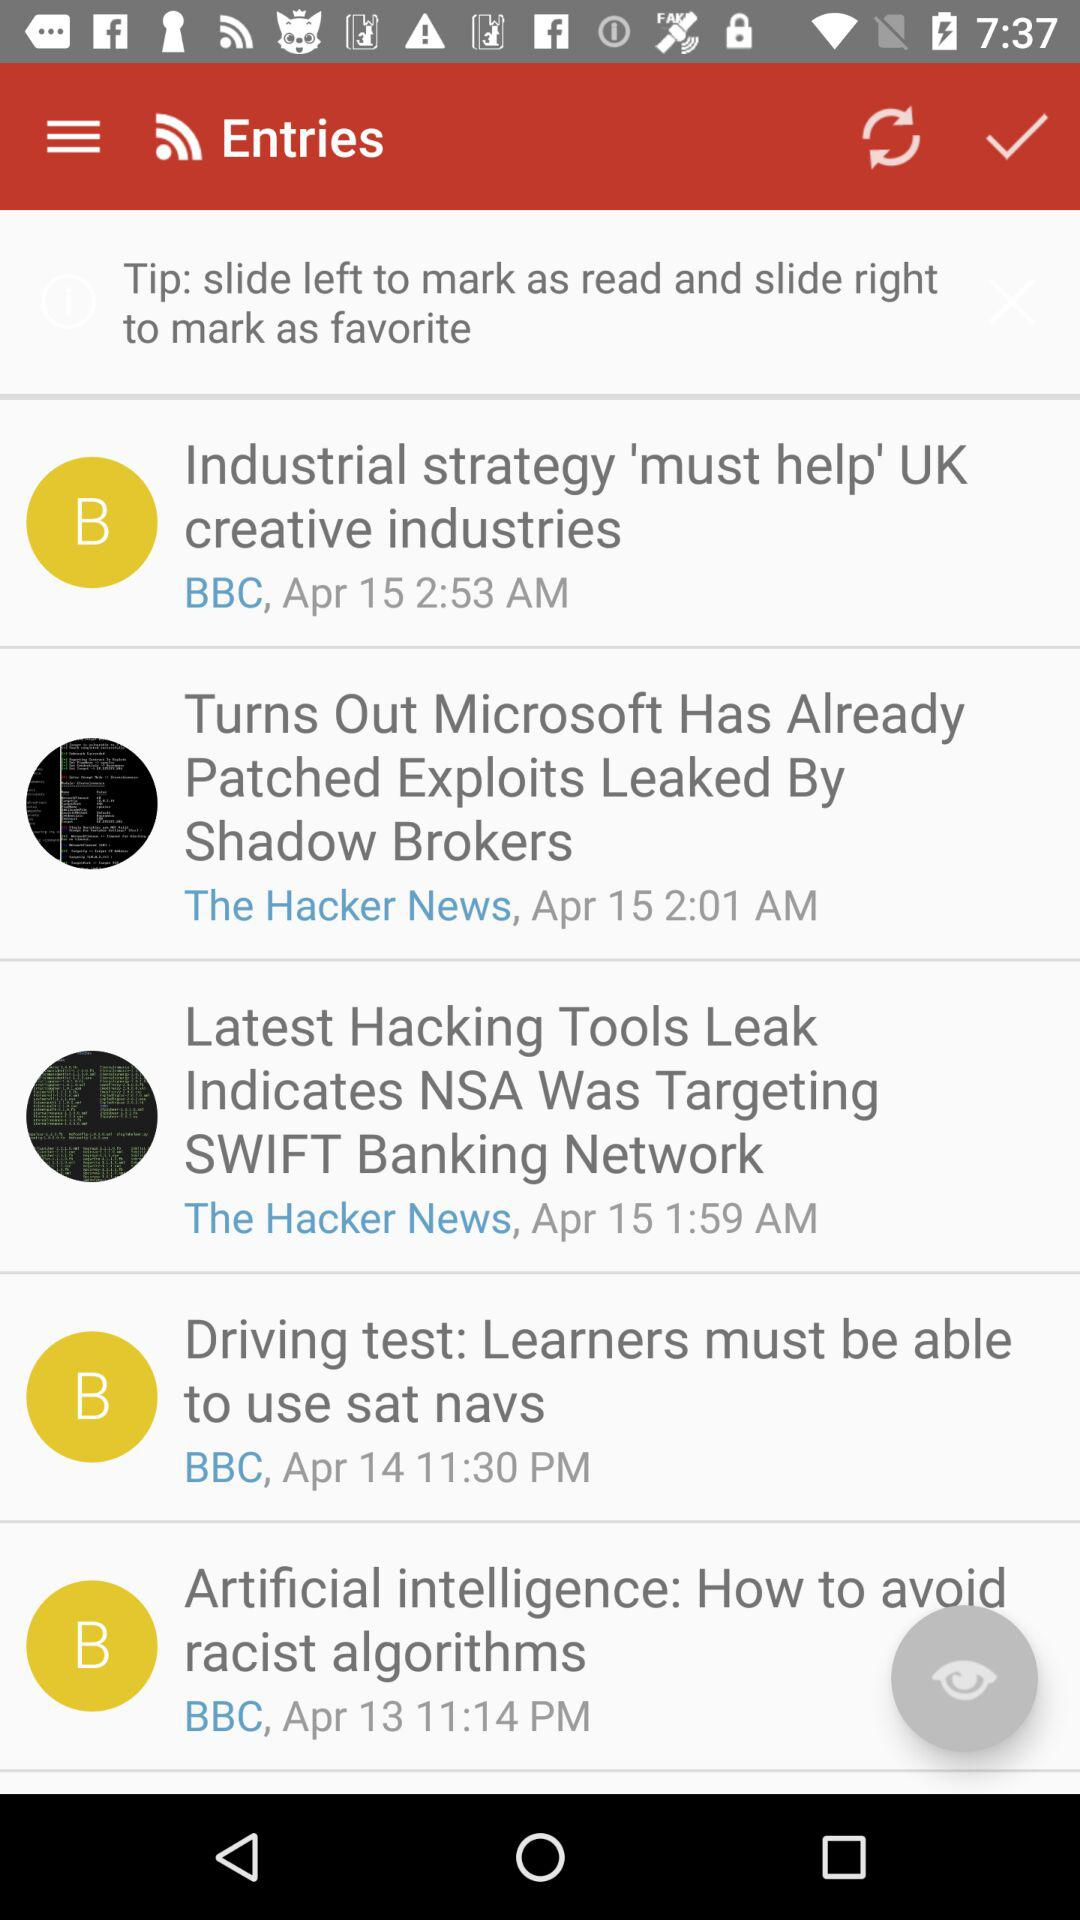What time was the news story "Latest Hacking Tools Leak Indicates NSA Was Targeting SWIFT Banking Network" published? The news story was published at 1:59 AM. 